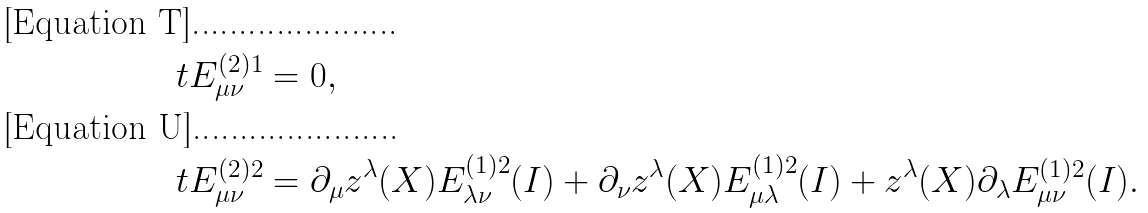<formula> <loc_0><loc_0><loc_500><loc_500>\ t E ^ { ( 2 ) 1 } _ { \mu \nu } & = 0 , \\ \ t E ^ { ( 2 ) 2 } _ { \mu \nu } & = \partial _ { \mu } z ^ { \lambda } ( X ) E ^ { ( 1 ) 2 } _ { \lambda \nu } ( I ) + \partial _ { \nu } z ^ { \lambda } ( X ) E ^ { ( 1 ) 2 } _ { \mu \lambda } ( I ) + z ^ { \lambda } ( X ) \partial _ { \lambda } E ^ { ( 1 ) 2 } _ { \mu \nu } ( I ) .</formula> 